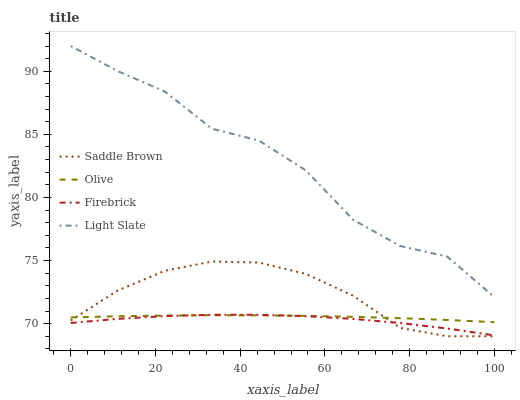Does Firebrick have the minimum area under the curve?
Answer yes or no. Yes. Does Light Slate have the maximum area under the curve?
Answer yes or no. Yes. Does Light Slate have the minimum area under the curve?
Answer yes or no. No. Does Firebrick have the maximum area under the curve?
Answer yes or no. No. Is Olive the smoothest?
Answer yes or no. Yes. Is Light Slate the roughest?
Answer yes or no. Yes. Is Firebrick the smoothest?
Answer yes or no. No. Is Firebrick the roughest?
Answer yes or no. No. Does Saddle Brown have the lowest value?
Answer yes or no. Yes. Does Firebrick have the lowest value?
Answer yes or no. No. Does Light Slate have the highest value?
Answer yes or no. Yes. Does Firebrick have the highest value?
Answer yes or no. No. Is Olive less than Light Slate?
Answer yes or no. Yes. Is Light Slate greater than Saddle Brown?
Answer yes or no. Yes. Does Saddle Brown intersect Firebrick?
Answer yes or no. Yes. Is Saddle Brown less than Firebrick?
Answer yes or no. No. Is Saddle Brown greater than Firebrick?
Answer yes or no. No. Does Olive intersect Light Slate?
Answer yes or no. No. 